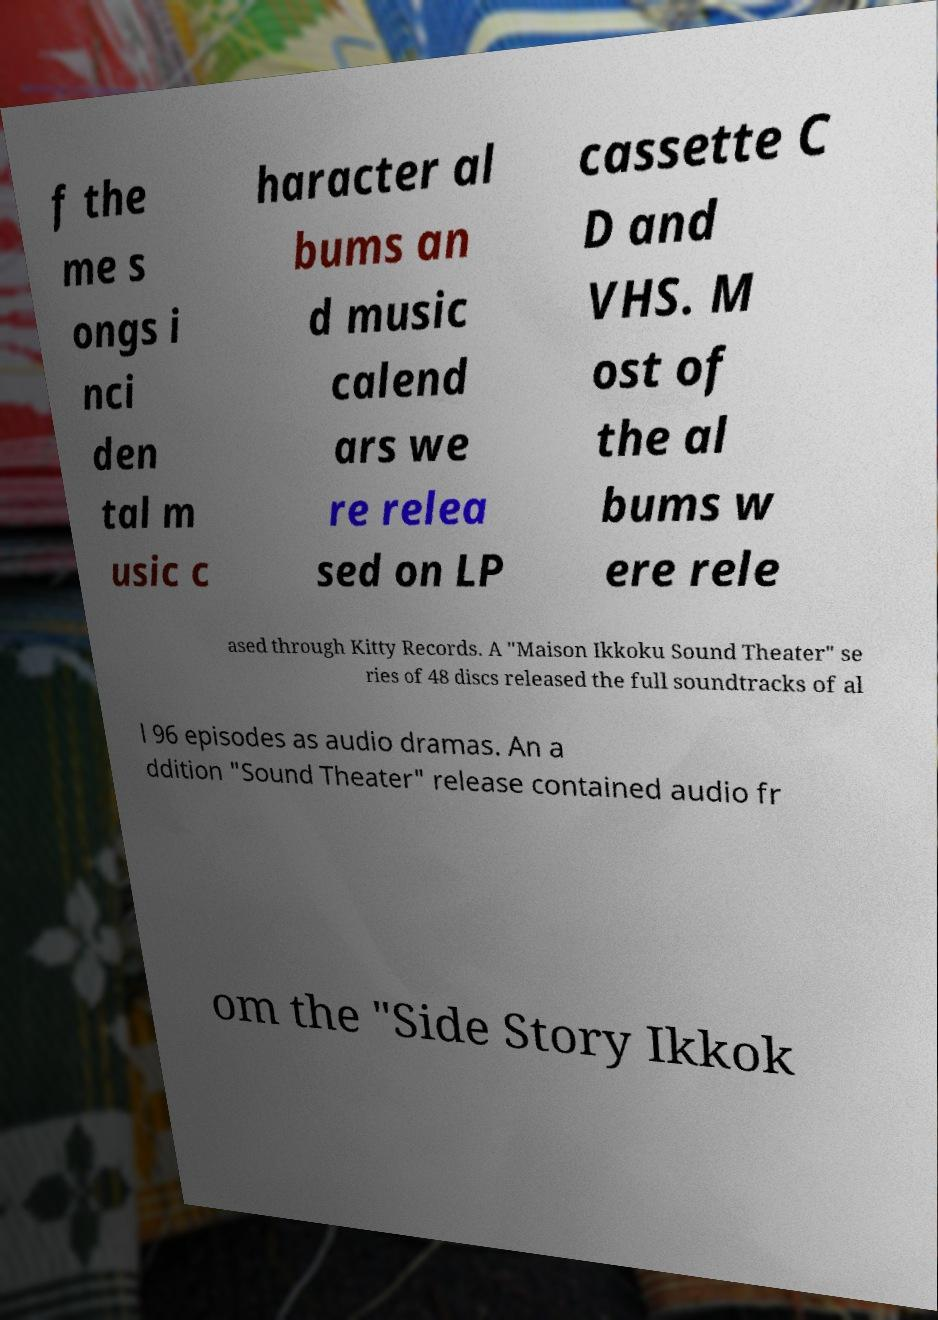There's text embedded in this image that I need extracted. Can you transcribe it verbatim? f the me s ongs i nci den tal m usic c haracter al bums an d music calend ars we re relea sed on LP cassette C D and VHS. M ost of the al bums w ere rele ased through Kitty Records. A "Maison Ikkoku Sound Theater" se ries of 48 discs released the full soundtracks of al l 96 episodes as audio dramas. An a ddition "Sound Theater" release contained audio fr om the "Side Story Ikkok 